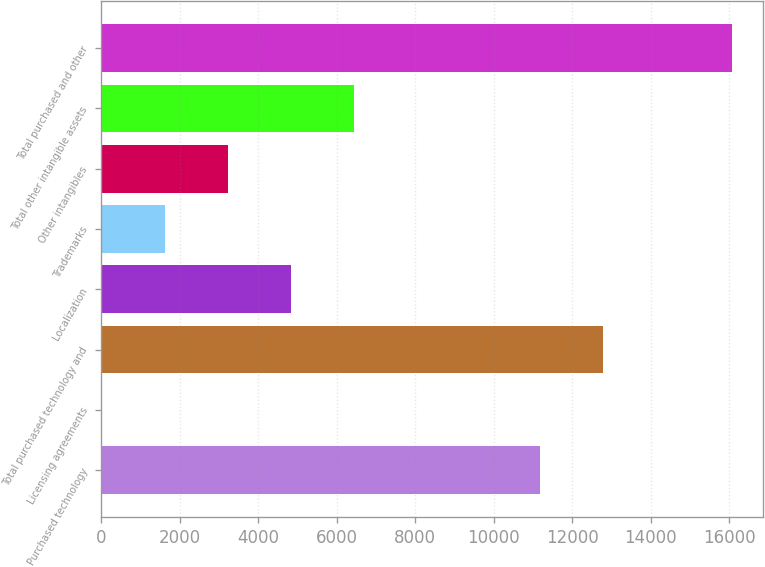Convert chart. <chart><loc_0><loc_0><loc_500><loc_500><bar_chart><fcel>Purchased technology<fcel>Licensing agreements<fcel>Total purchased technology and<fcel>Localization<fcel>Trademarks<fcel>Other intangibles<fcel>Total other intangible assets<fcel>Total purchased and other<nl><fcel>11171<fcel>21<fcel>12775.6<fcel>4834.8<fcel>1625.6<fcel>3230.2<fcel>6439.4<fcel>16067<nl></chart> 